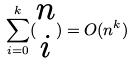Convert formula to latex. <formula><loc_0><loc_0><loc_500><loc_500>\sum _ { i = 0 } ^ { k } ( \begin{matrix} n \\ i \end{matrix} ) = O ( n ^ { k } )</formula> 